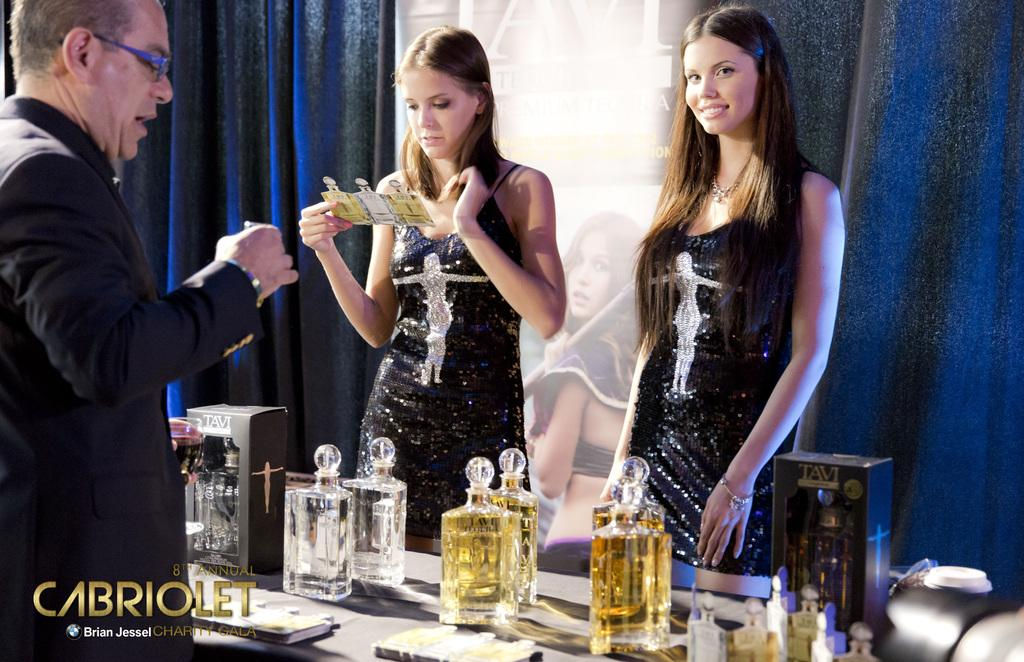<image>
Render a clear and concise summary of the photo. Some women serve liquor in a Cabriolet ad. 